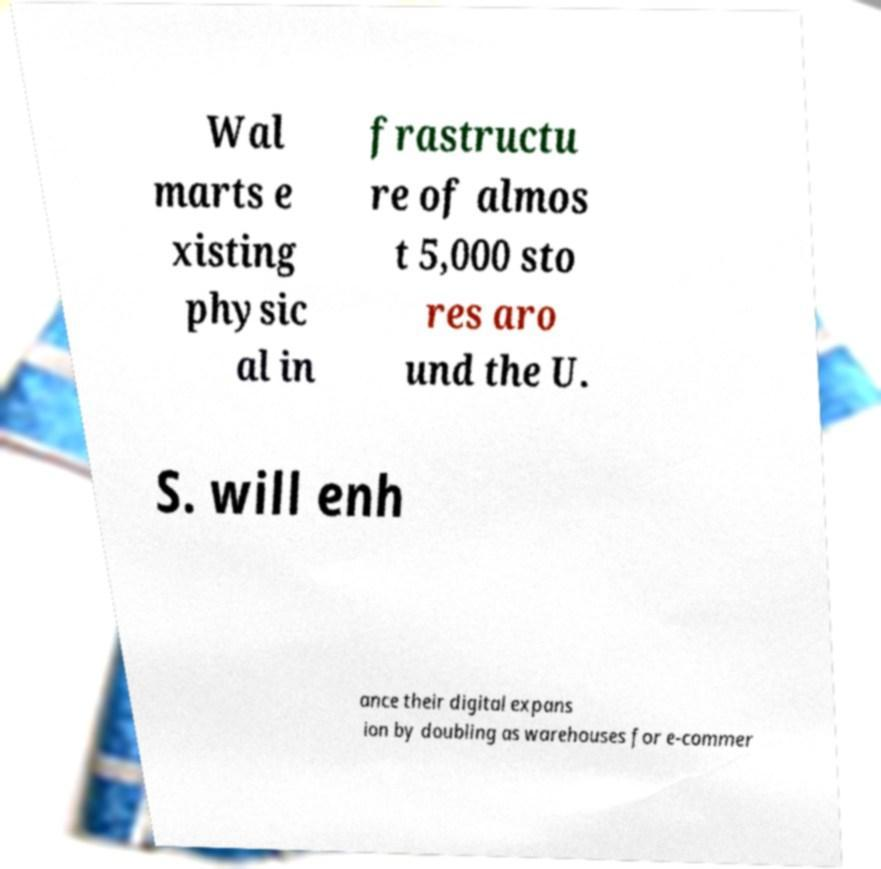Could you extract and type out the text from this image? Wal marts e xisting physic al in frastructu re of almos t 5,000 sto res aro und the U. S. will enh ance their digital expans ion by doubling as warehouses for e-commer 